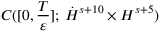Convert formula to latex. <formula><loc_0><loc_0><loc_500><loc_500>C ( [ 0 , \frac { T } { \varepsilon } ] ; \, \dot { H } ^ { s + 1 0 } \times H ^ { s + 5 } )</formula> 